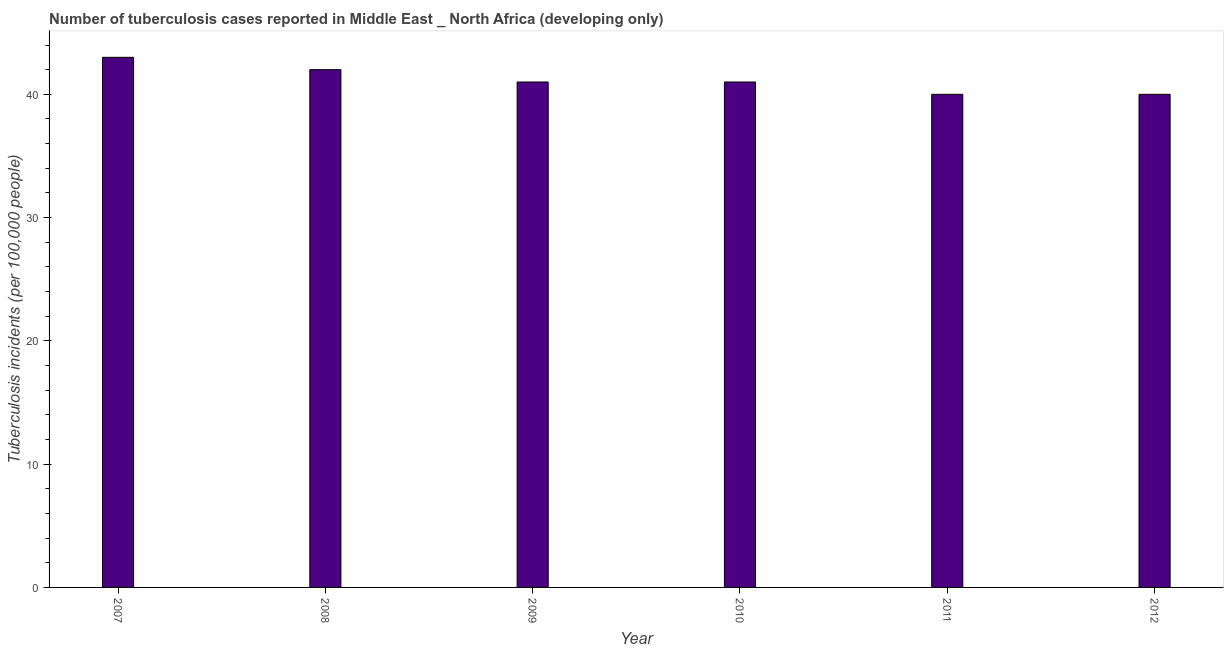Does the graph contain any zero values?
Your answer should be very brief. No. Does the graph contain grids?
Your answer should be very brief. No. What is the title of the graph?
Give a very brief answer. Number of tuberculosis cases reported in Middle East _ North Africa (developing only). What is the label or title of the Y-axis?
Ensure brevity in your answer.  Tuberculosis incidents (per 100,0 people). What is the number of tuberculosis incidents in 2012?
Your response must be concise. 40. Across all years, what is the maximum number of tuberculosis incidents?
Give a very brief answer. 43. In which year was the number of tuberculosis incidents minimum?
Keep it short and to the point. 2011. What is the sum of the number of tuberculosis incidents?
Give a very brief answer. 247. In how many years, is the number of tuberculosis incidents greater than 2 ?
Your answer should be very brief. 6. Do a majority of the years between 2010 and 2012 (inclusive) have number of tuberculosis incidents greater than 24 ?
Keep it short and to the point. Yes. What is the ratio of the number of tuberculosis incidents in 2007 to that in 2011?
Offer a terse response. 1.07. Is the number of tuberculosis incidents in 2007 less than that in 2010?
Offer a terse response. No. Is the sum of the number of tuberculosis incidents in 2009 and 2012 greater than the maximum number of tuberculosis incidents across all years?
Ensure brevity in your answer.  Yes. Are all the bars in the graph horizontal?
Offer a terse response. No. How many years are there in the graph?
Keep it short and to the point. 6. What is the difference between two consecutive major ticks on the Y-axis?
Offer a terse response. 10. What is the Tuberculosis incidents (per 100,000 people) in 2007?
Provide a succinct answer. 43. What is the Tuberculosis incidents (per 100,000 people) in 2008?
Ensure brevity in your answer.  42. What is the Tuberculosis incidents (per 100,000 people) of 2011?
Your answer should be very brief. 40. What is the Tuberculosis incidents (per 100,000 people) of 2012?
Keep it short and to the point. 40. What is the difference between the Tuberculosis incidents (per 100,000 people) in 2007 and 2008?
Provide a succinct answer. 1. What is the difference between the Tuberculosis incidents (per 100,000 people) in 2007 and 2011?
Your answer should be compact. 3. What is the difference between the Tuberculosis incidents (per 100,000 people) in 2008 and 2010?
Your answer should be very brief. 1. What is the difference between the Tuberculosis incidents (per 100,000 people) in 2008 and 2012?
Provide a succinct answer. 2. What is the difference between the Tuberculosis incidents (per 100,000 people) in 2009 and 2010?
Make the answer very short. 0. What is the difference between the Tuberculosis incidents (per 100,000 people) in 2010 and 2012?
Make the answer very short. 1. What is the difference between the Tuberculosis incidents (per 100,000 people) in 2011 and 2012?
Offer a very short reply. 0. What is the ratio of the Tuberculosis incidents (per 100,000 people) in 2007 to that in 2008?
Provide a succinct answer. 1.02. What is the ratio of the Tuberculosis incidents (per 100,000 people) in 2007 to that in 2009?
Make the answer very short. 1.05. What is the ratio of the Tuberculosis incidents (per 100,000 people) in 2007 to that in 2010?
Your response must be concise. 1.05. What is the ratio of the Tuberculosis incidents (per 100,000 people) in 2007 to that in 2011?
Offer a terse response. 1.07. What is the ratio of the Tuberculosis incidents (per 100,000 people) in 2007 to that in 2012?
Your response must be concise. 1.07. What is the ratio of the Tuberculosis incidents (per 100,000 people) in 2008 to that in 2012?
Your answer should be very brief. 1.05. What is the ratio of the Tuberculosis incidents (per 100,000 people) in 2009 to that in 2010?
Keep it short and to the point. 1. What is the ratio of the Tuberculosis incidents (per 100,000 people) in 2009 to that in 2011?
Give a very brief answer. 1.02. What is the ratio of the Tuberculosis incidents (per 100,000 people) in 2009 to that in 2012?
Provide a succinct answer. 1.02. What is the ratio of the Tuberculosis incidents (per 100,000 people) in 2010 to that in 2011?
Provide a short and direct response. 1.02. 